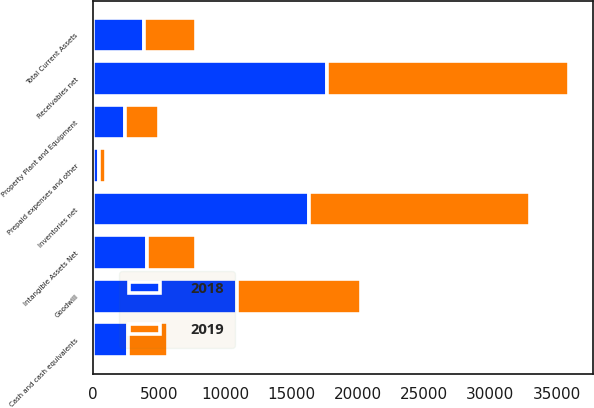Convert chart to OTSL. <chart><loc_0><loc_0><loc_500><loc_500><stacked_bar_chart><ecel><fcel>Cash and cash equivalents<fcel>Receivables net<fcel>Inventories net<fcel>Prepaid expenses and other<fcel>Total Current Assets<fcel>Property Plant and Equipment<fcel>Goodwill<fcel>Intangible Assets Net<nl><fcel>2019<fcel>2981<fcel>18246<fcel>16709<fcel>529<fcel>3895.5<fcel>2548<fcel>9358<fcel>3689<nl><fcel>2018<fcel>2672<fcel>17711<fcel>16310<fcel>443<fcel>3895.5<fcel>2464<fcel>10924<fcel>4102<nl></chart> 